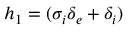Convert formula to latex. <formula><loc_0><loc_0><loc_500><loc_500>h _ { 1 } = ( \sigma _ { i } \delta _ { e } + \delta _ { i } )</formula> 